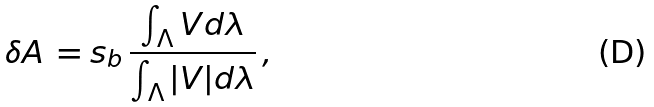Convert formula to latex. <formula><loc_0><loc_0><loc_500><loc_500>\delta A \, = s _ { b } \, \frac { \int _ { \Lambda } V d \lambda } { \int _ { \Lambda } | V | d \lambda } \, ,</formula> 